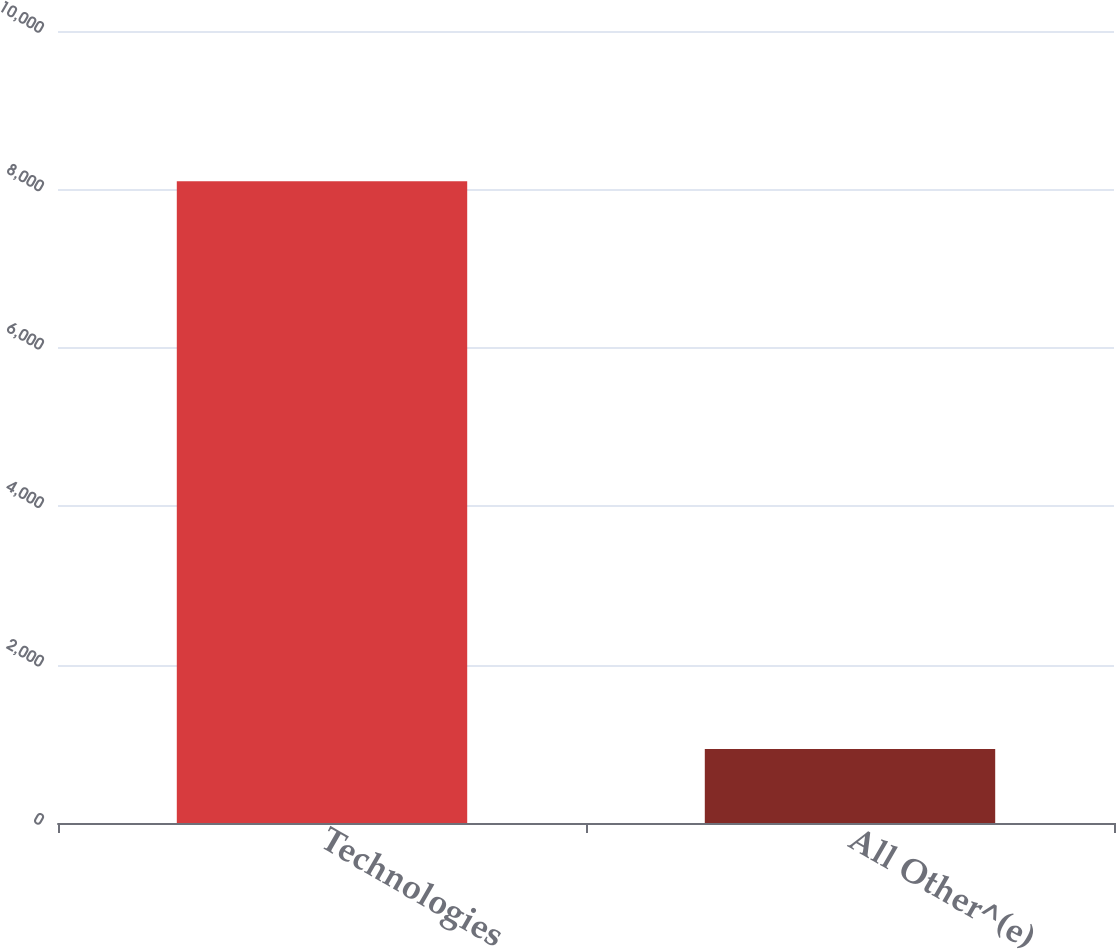Convert chart to OTSL. <chart><loc_0><loc_0><loc_500><loc_500><bar_chart><fcel>Technologies<fcel>All Other^(e)<nl><fcel>8103.7<fcel>935.8<nl></chart> 